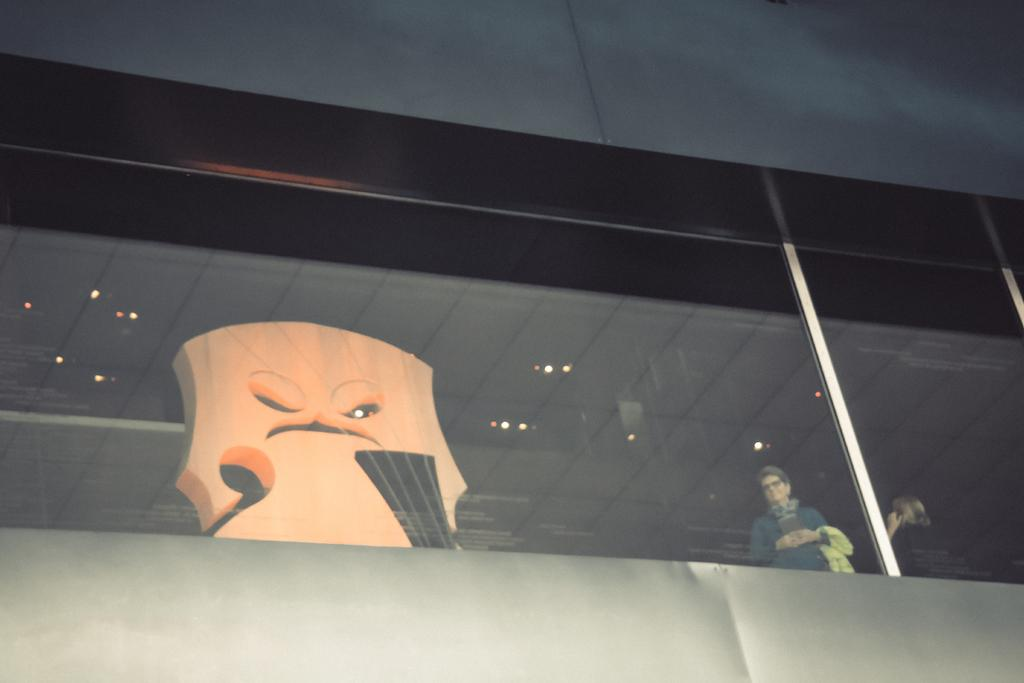What type of structure is present in the image? There is a building in the image. Can you describe any decorative elements in the building? There is a decor in the building. Are there any people visible in the image? People are visible through the glass in the building. What type of polish is being applied to the fifth person in the image? There is no mention of polish or any specific person in the image; it only shows a building with decor and people visible through the glass. 